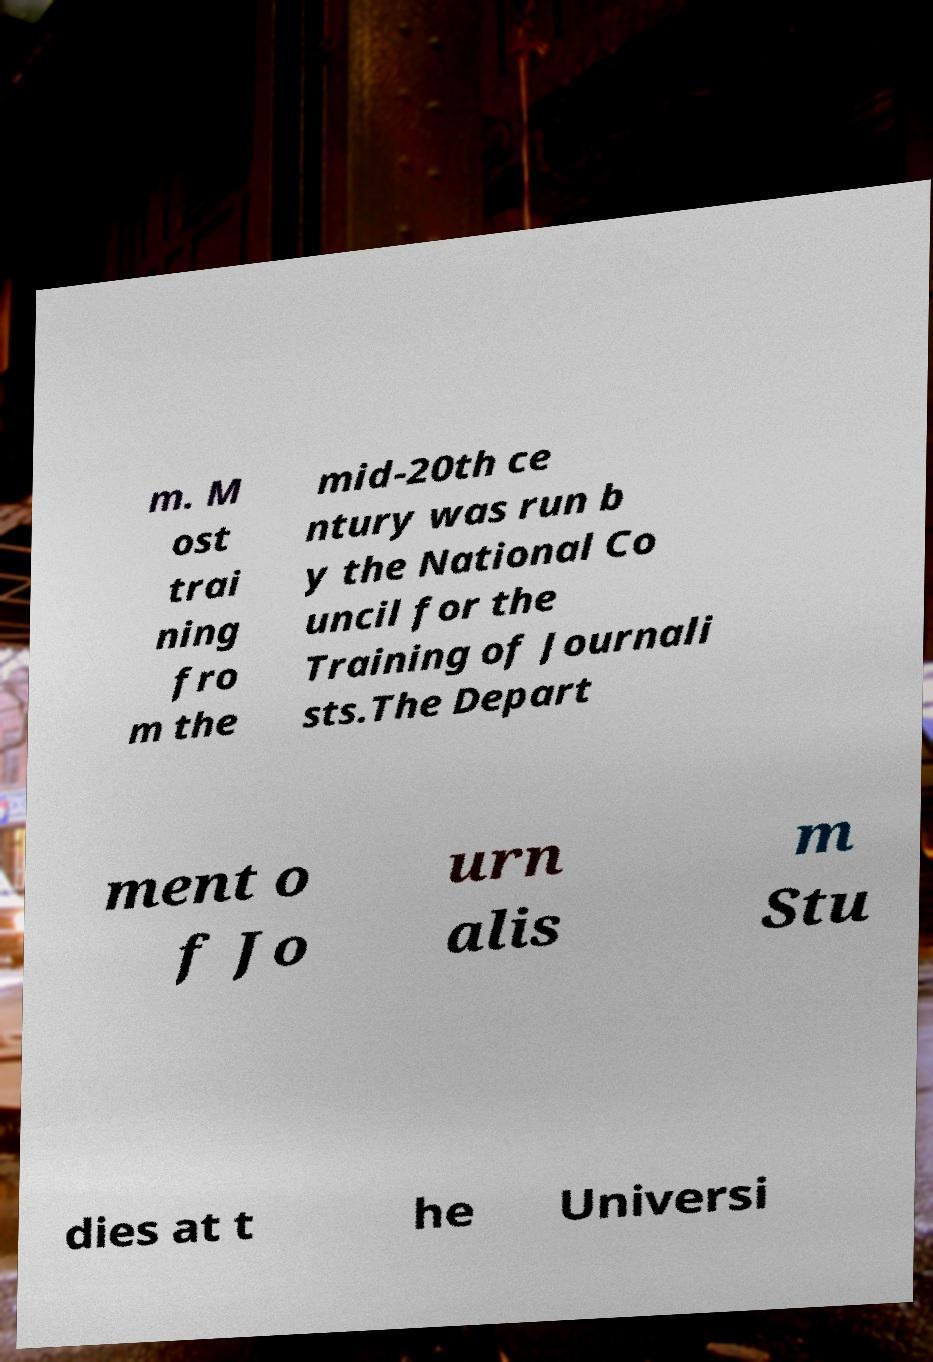Please identify and transcribe the text found in this image. m. M ost trai ning fro m the mid-20th ce ntury was run b y the National Co uncil for the Training of Journali sts.The Depart ment o f Jo urn alis m Stu dies at t he Universi 